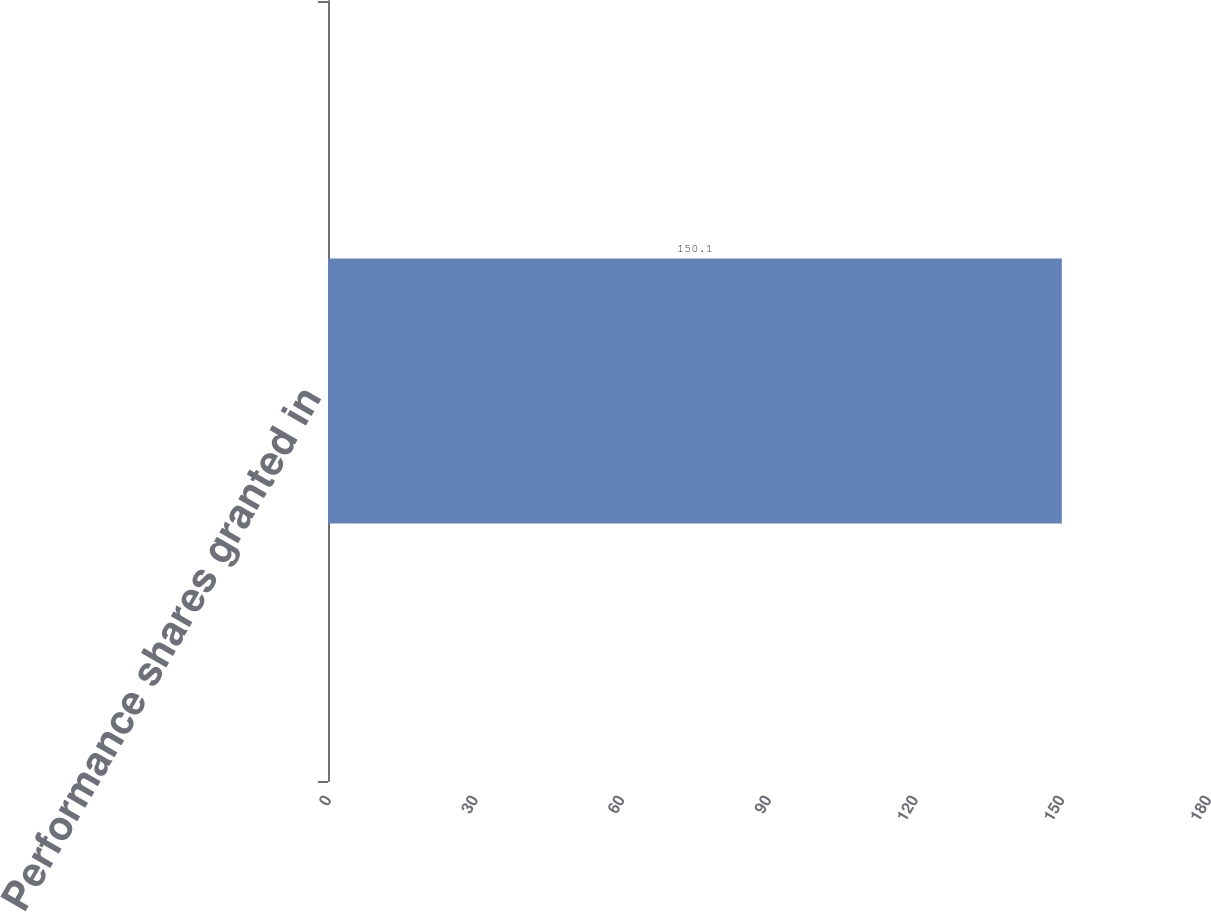Convert chart to OTSL. <chart><loc_0><loc_0><loc_500><loc_500><bar_chart><fcel>Performance shares granted in<nl><fcel>150.1<nl></chart> 